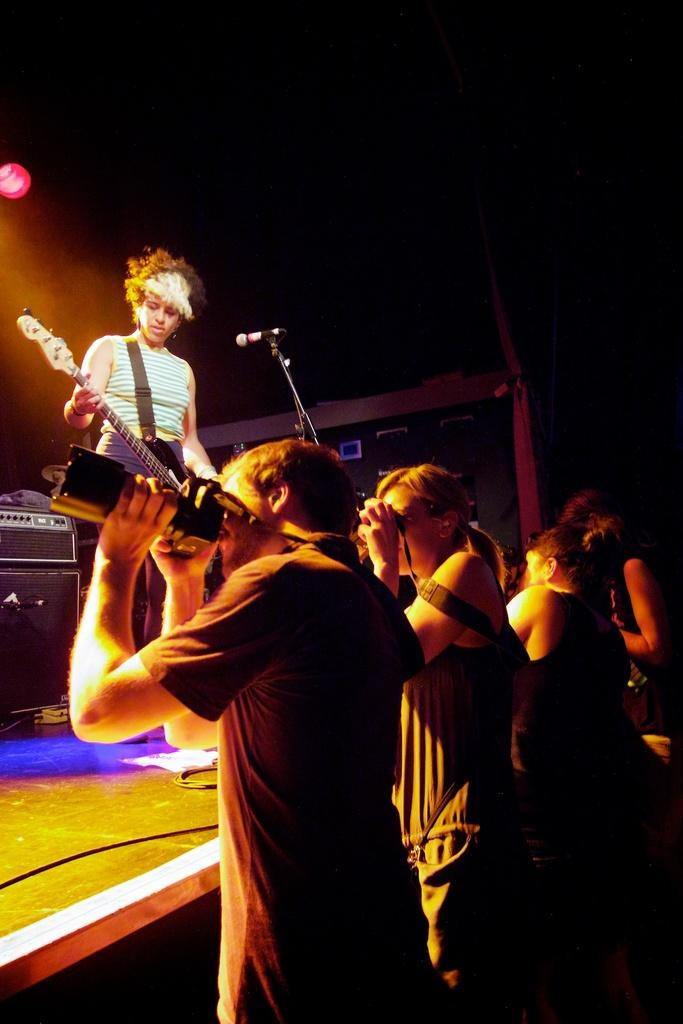What is happening in the image involving a group of people? There are people standing in a group in the image. What is the woman on the stage doing? The woman is standing on a stage and holding a guitar. What is the woman likely to use in the image? The woman is likely to use the microphone in front of her. What type of apparatus is the woman using to bake a pie in the image? There is no apparatus for baking a pie present in the image, nor is the woman engaged in any baking activity. Can you tell me the name of the woman's grandfather in the image? There is no information about the woman's grandfather in the image, as the focus is on her standing on a stage with a guitar and a microphone. 